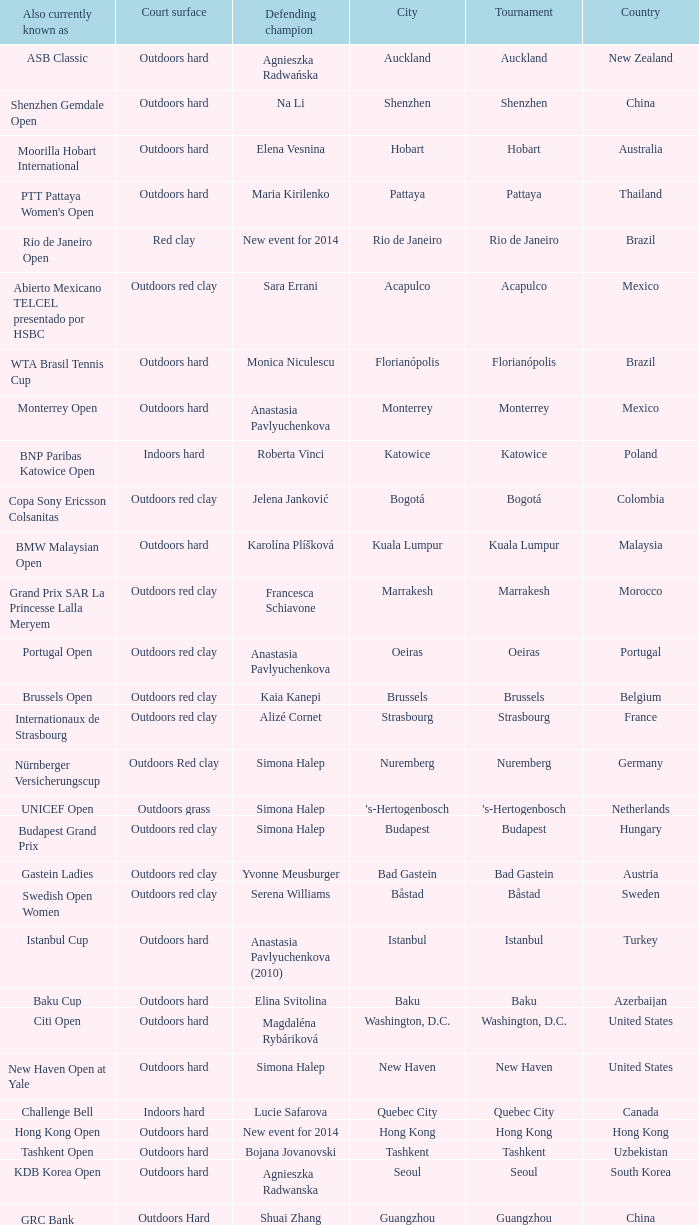What tournament is in katowice? Katowice. 